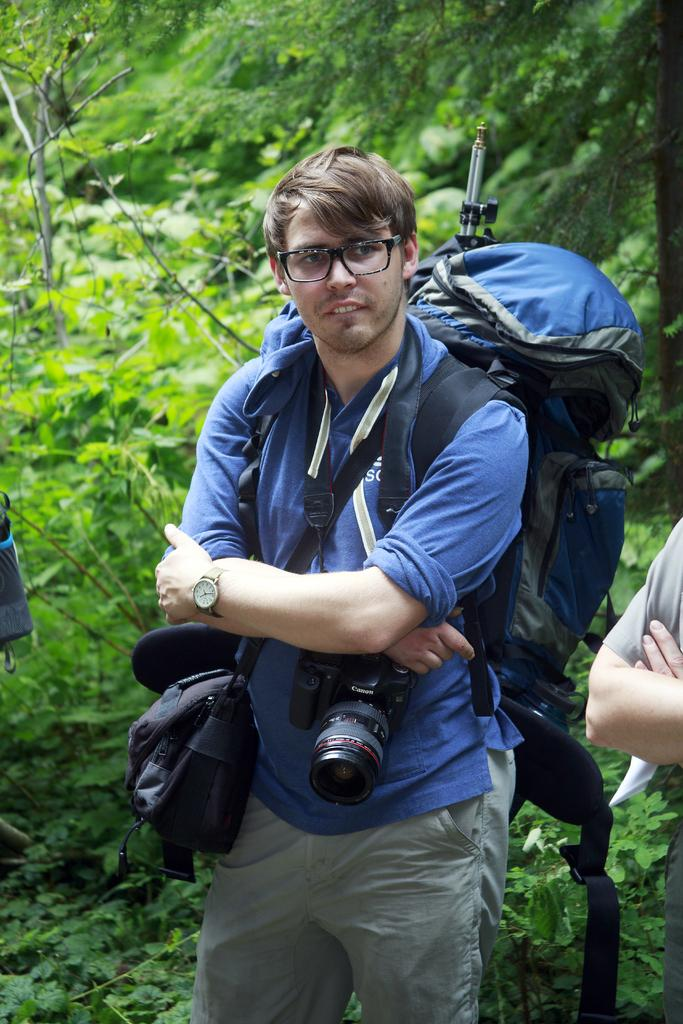What is the person in the image wearing? The person is wearing a blue jacket. What is the person doing in the image? The person is standing. What accessory can be seen on the person's left hand? The person has a watch on their left hand. What objects are present in the image besides the person? There is a bag and a camera in the image. What can be seen in the background of the image? There is a tree visible in the background of the image. How many cherries are hanging from the tree in the background of the image? There are no cherries visible in the image; only a tree can be seen in the background. Can you tell me how many friends are standing next to the person in the image? There is no indication of any friends in the image; only the person wearing a blue jacket is visible. 